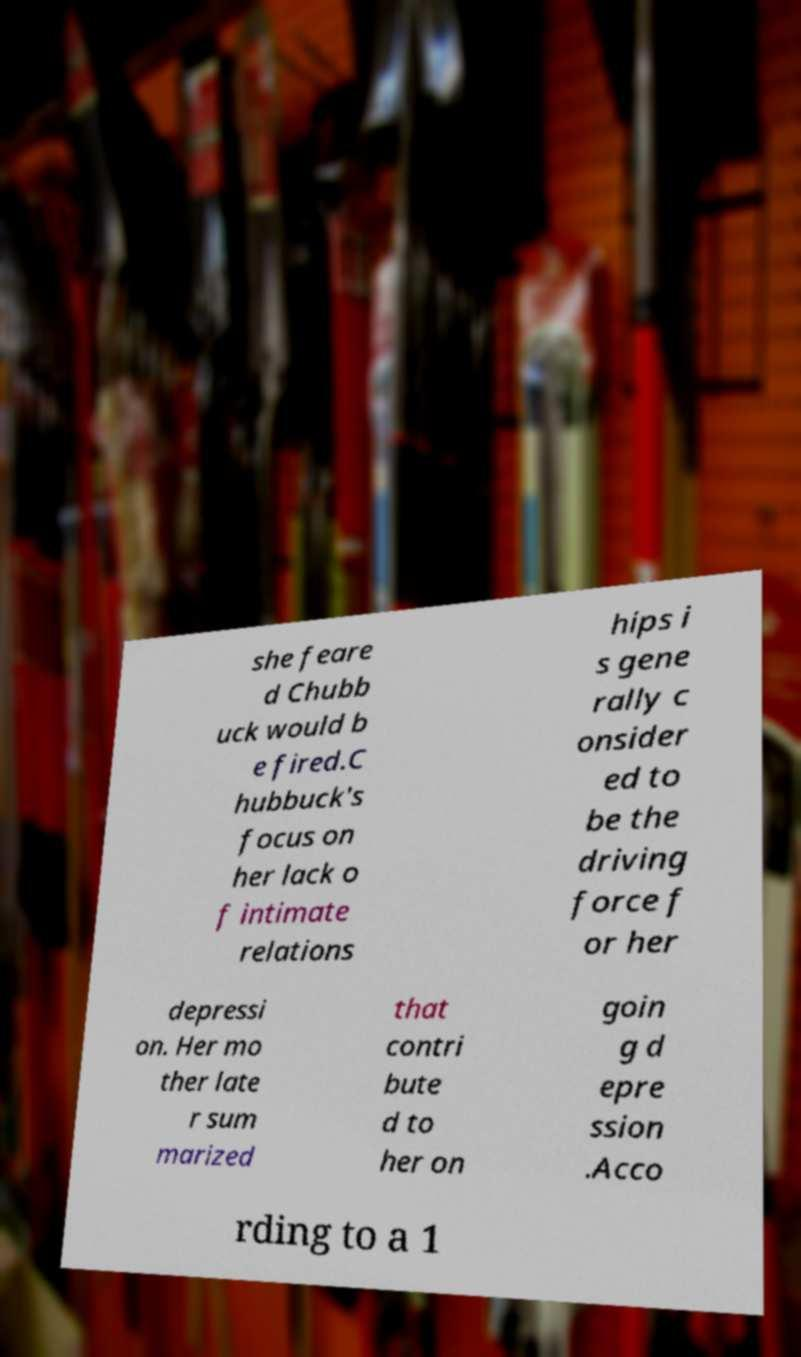Please identify and transcribe the text found in this image. she feare d Chubb uck would b e fired.C hubbuck's focus on her lack o f intimate relations hips i s gene rally c onsider ed to be the driving force f or her depressi on. Her mo ther late r sum marized that contri bute d to her on goin g d epre ssion .Acco rding to a 1 